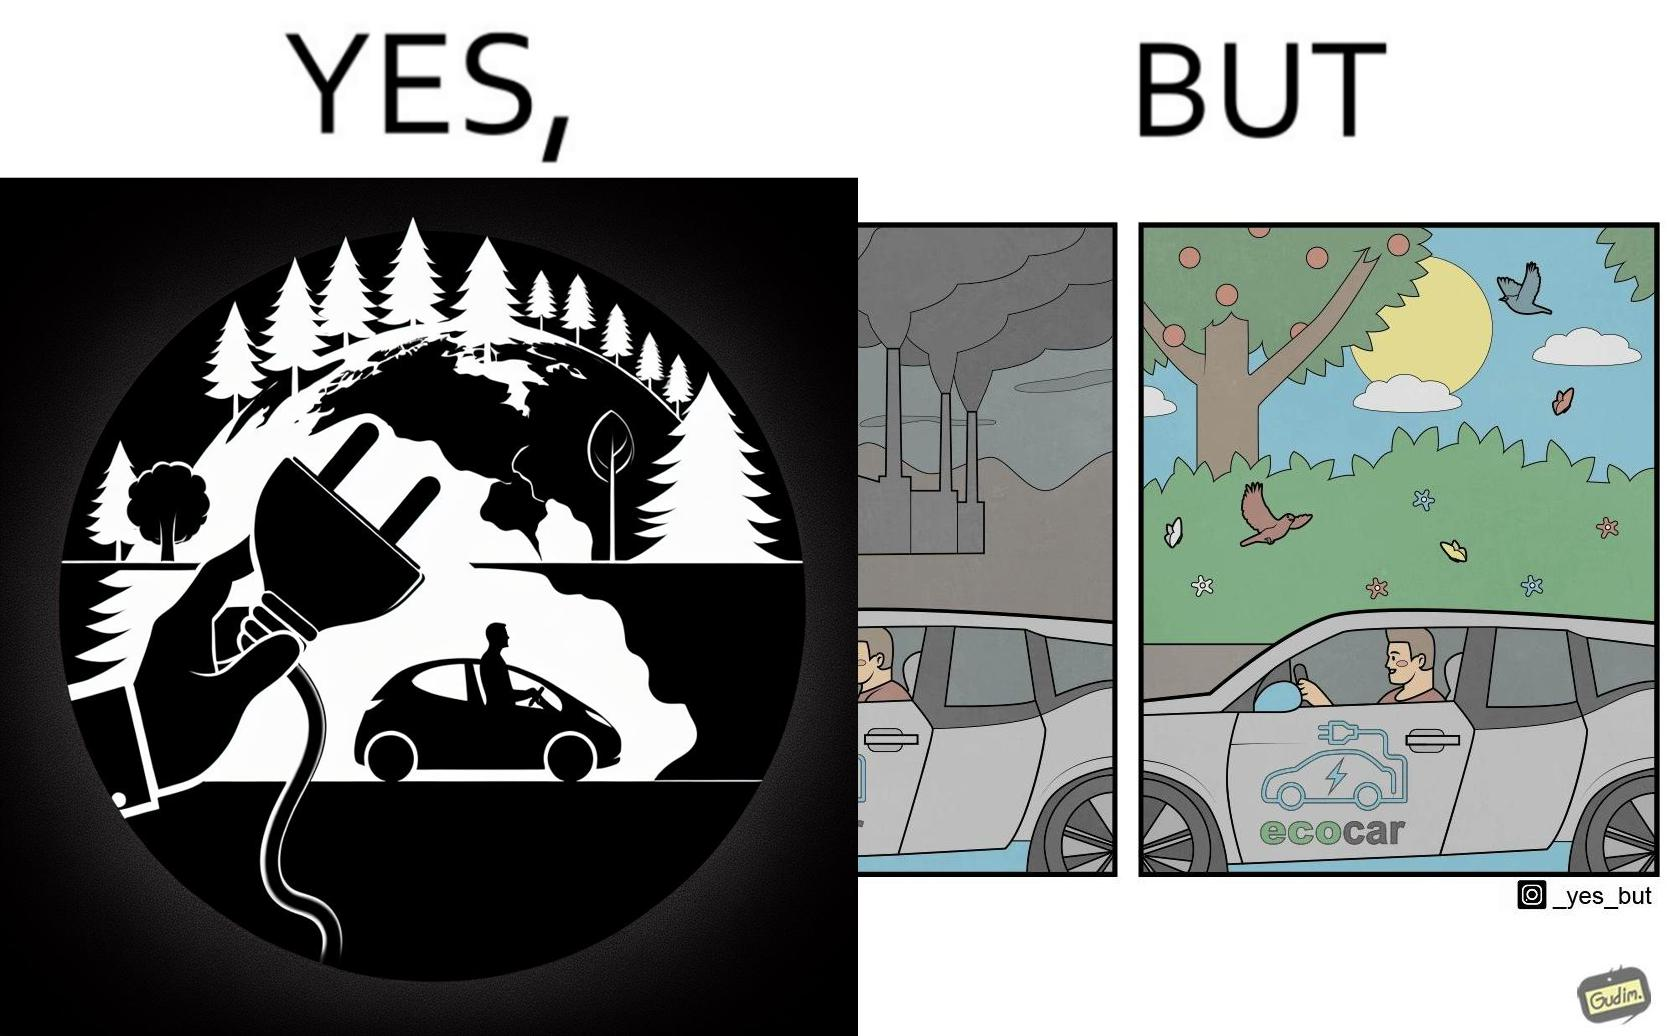Compare the left and right sides of this image. In the left part of the image: Image showing how using electric powered vehicles helps make the world a greener place In the right part of the image: Image showing the vast amount of pollution caused during production of batteries 